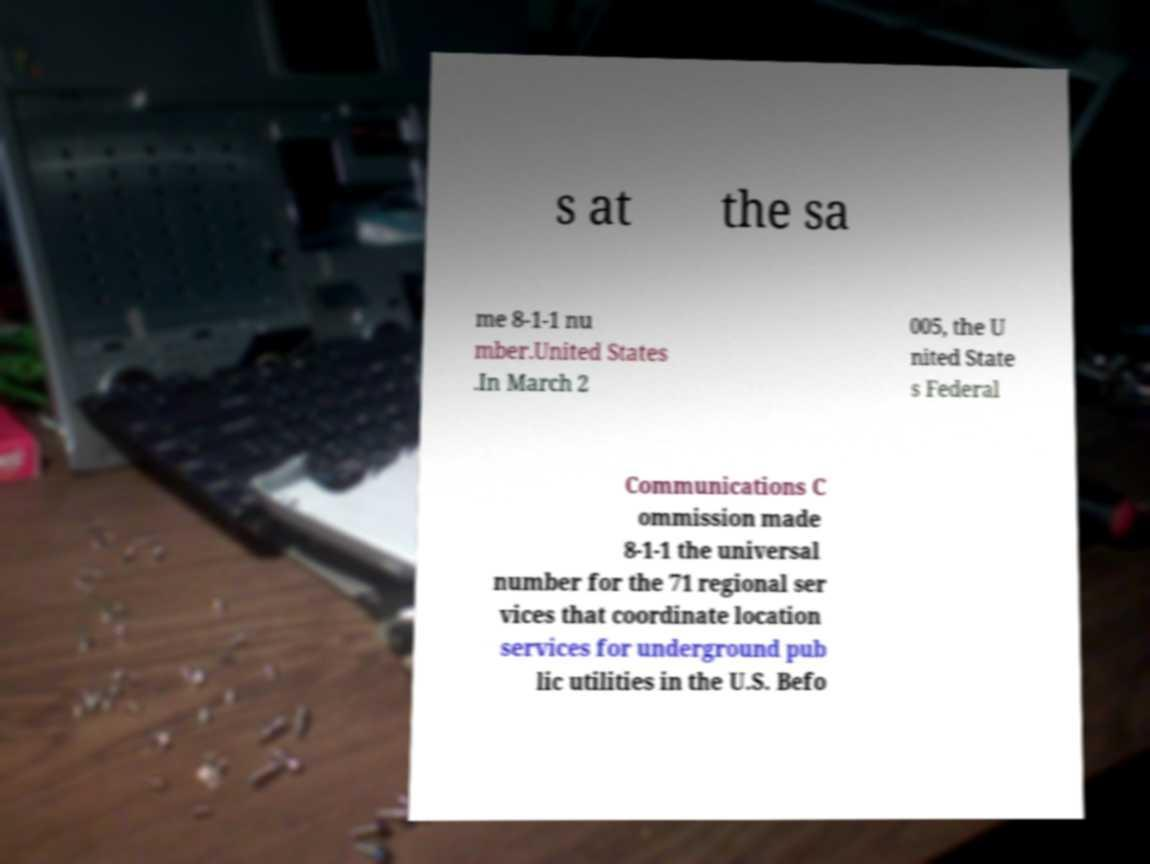Could you extract and type out the text from this image? s at the sa me 8-1-1 nu mber.United States .In March 2 005, the U nited State s Federal Communications C ommission made 8-1-1 the universal number for the 71 regional ser vices that coordinate location services for underground pub lic utilities in the U.S. Befo 